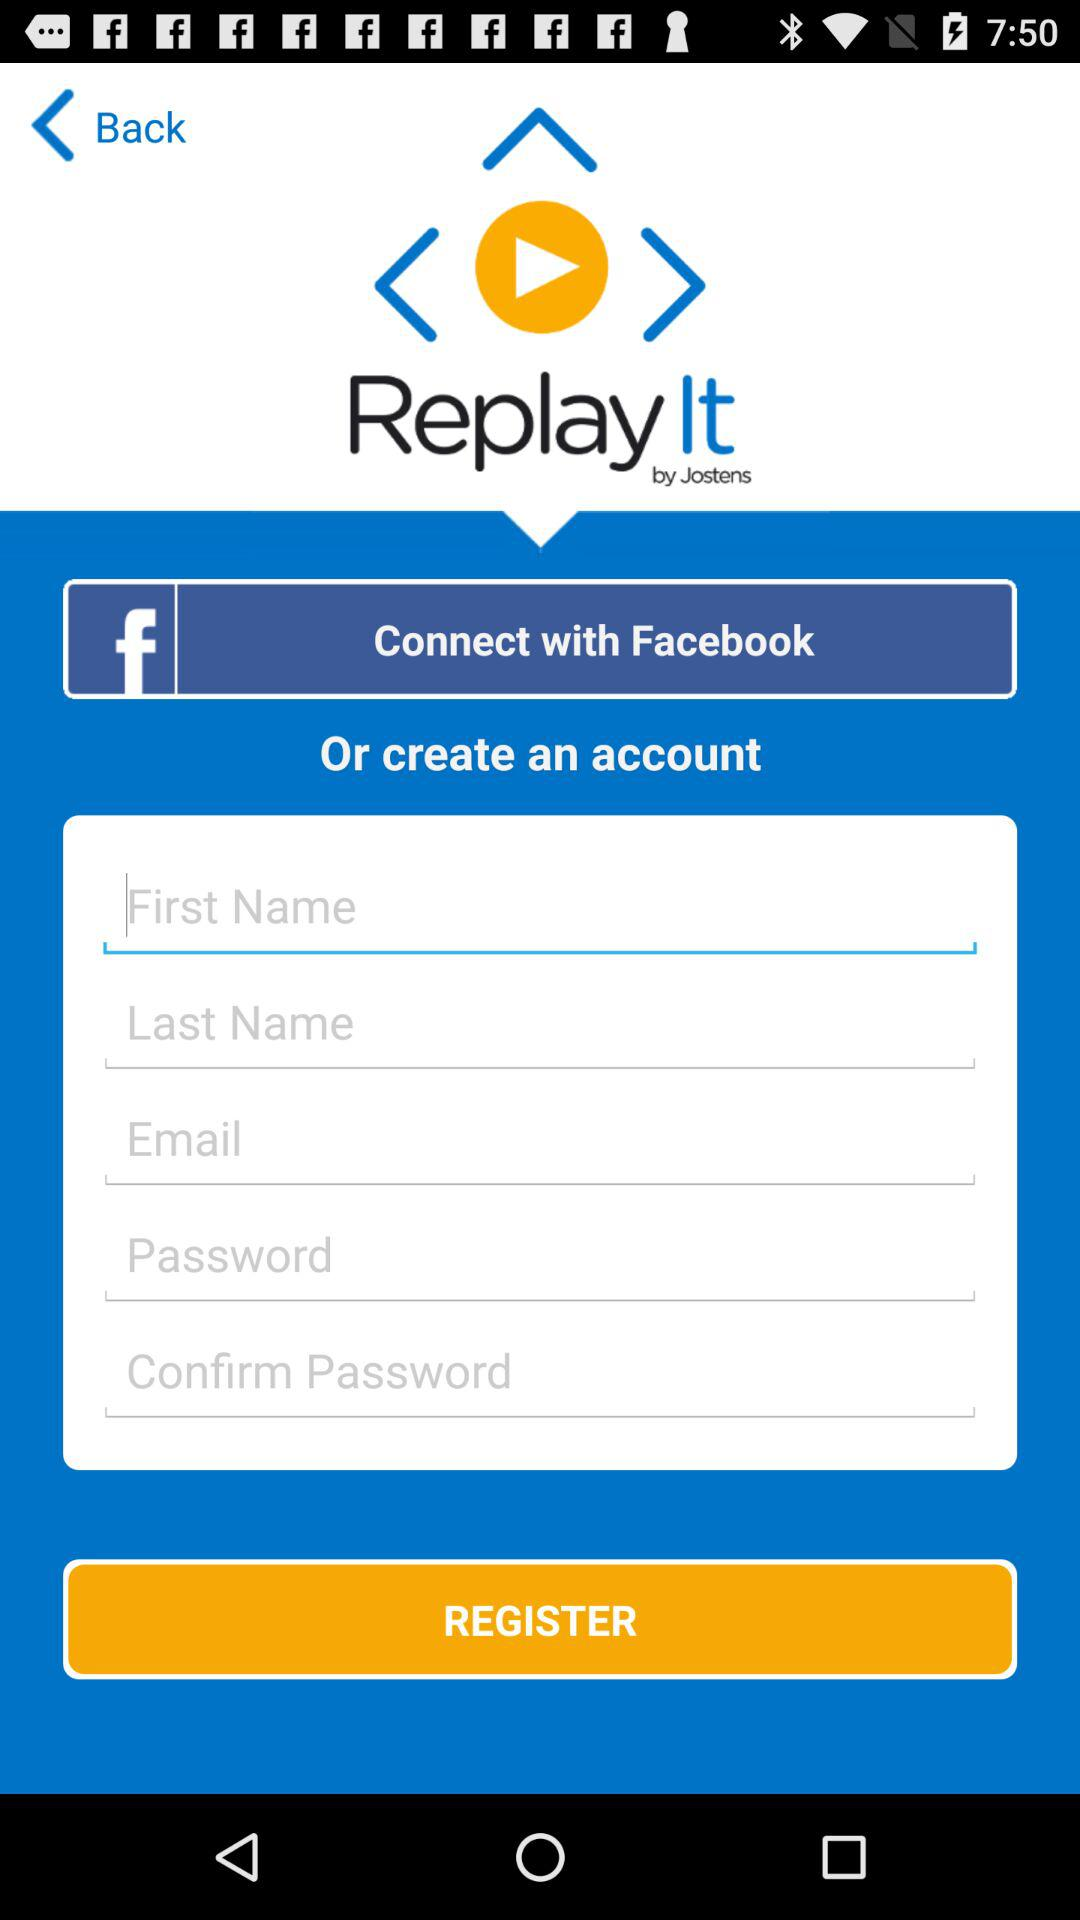What is the app name? The app name is "Replay It". 